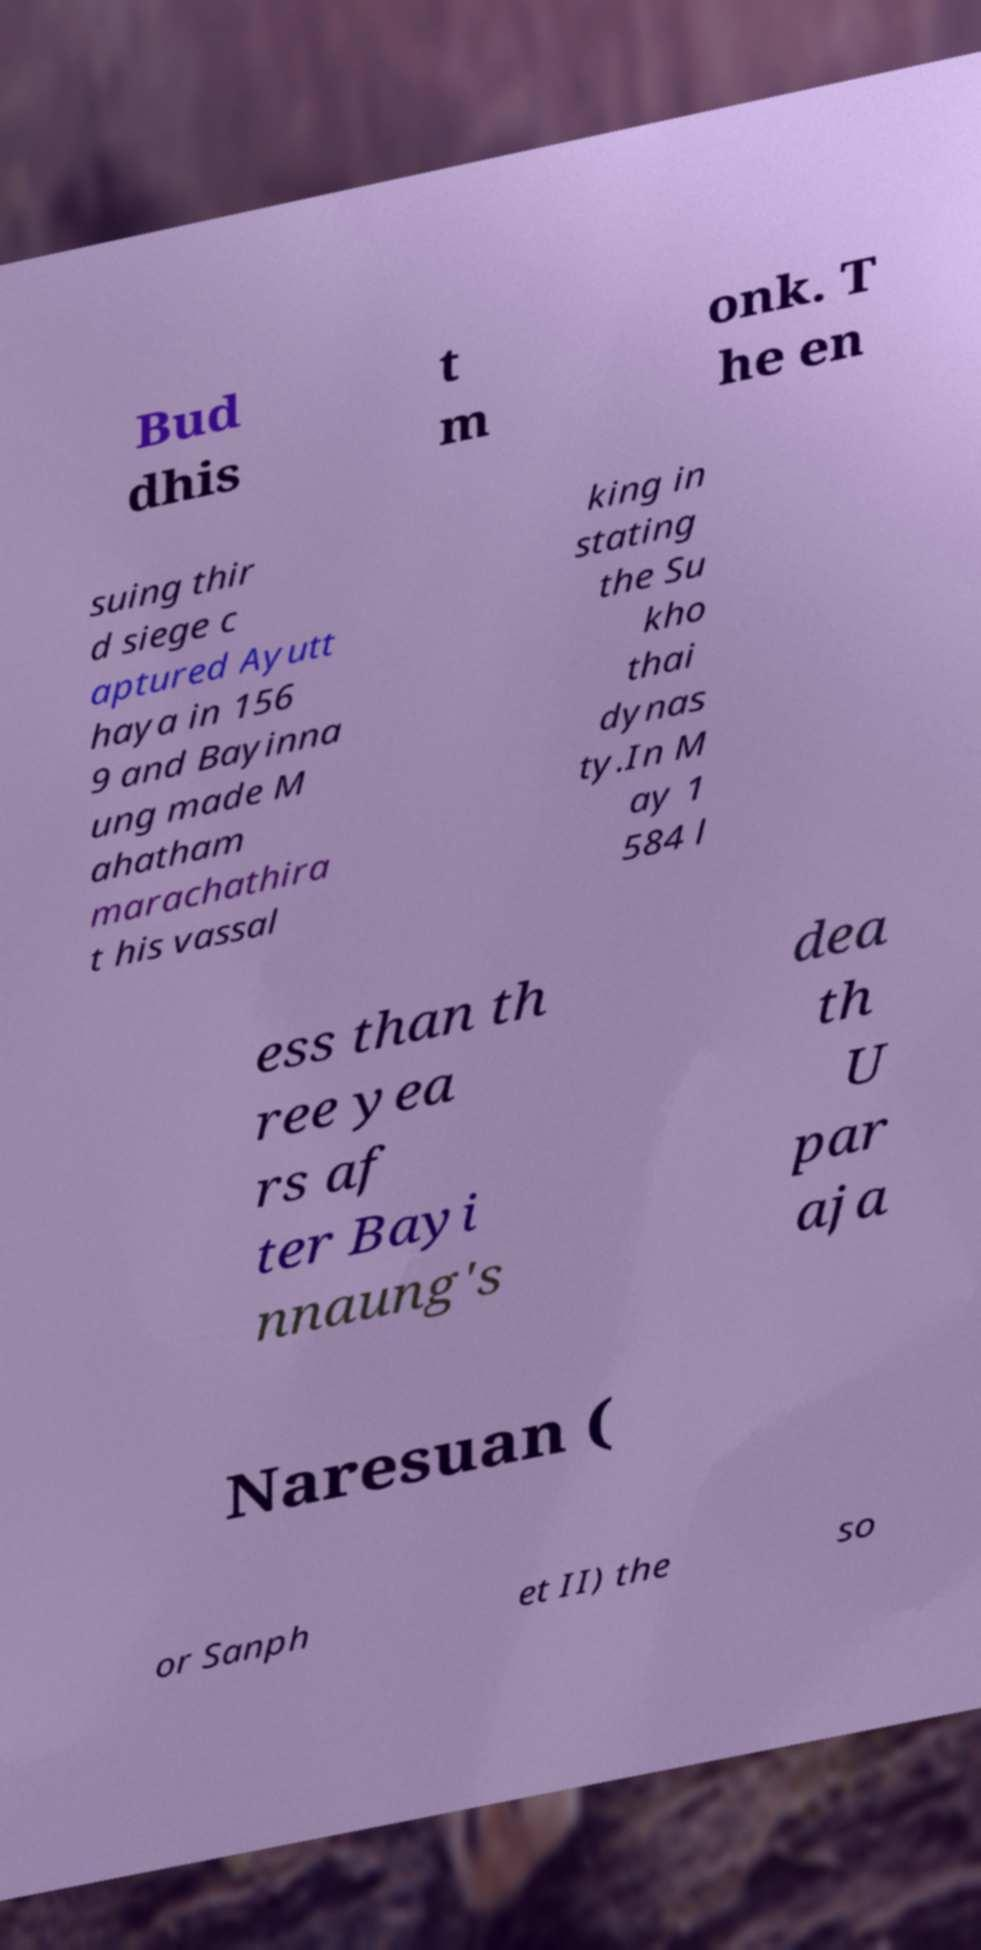What messages or text are displayed in this image? I need them in a readable, typed format. Bud dhis t m onk. T he en suing thir d siege c aptured Ayutt haya in 156 9 and Bayinna ung made M ahatham marachathira t his vassal king in stating the Su kho thai dynas ty.In M ay 1 584 l ess than th ree yea rs af ter Bayi nnaung's dea th U par aja Naresuan ( or Sanph et II) the so 